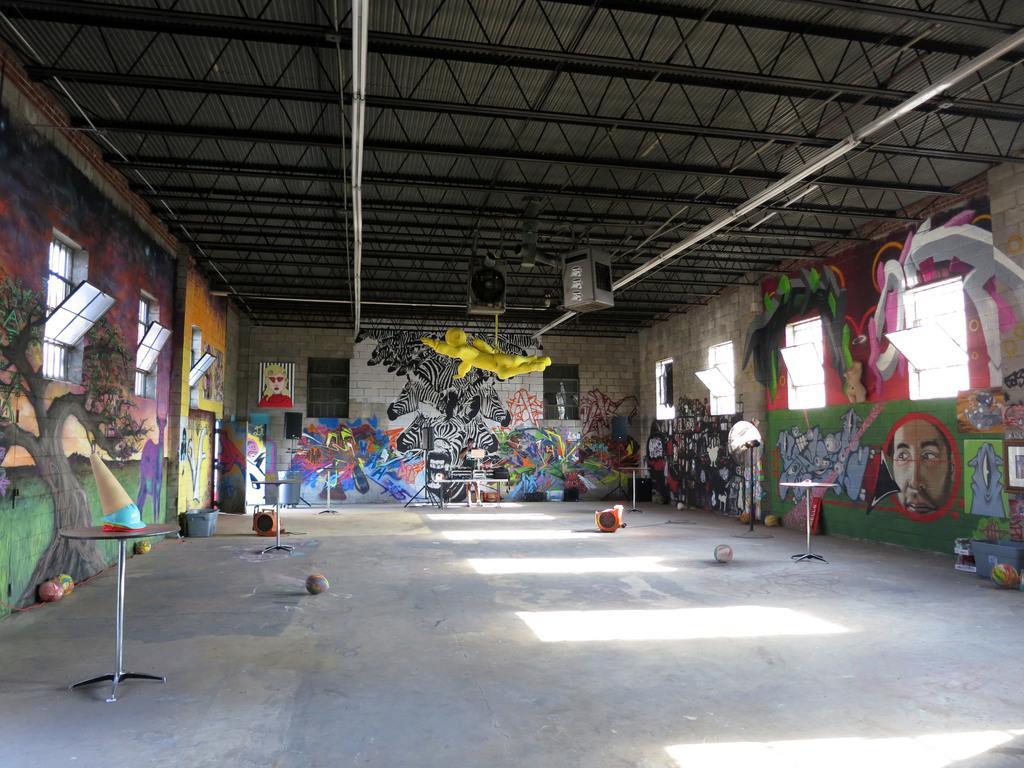Can you describe this image briefly? This picture is taken in a room. There is a table having an object on it. There are few balls and basket are on the floor. Sound speakers are attached to the roads which are fixed to the roof. To the wall there are few windows. Few pictures are painted on the wall. 